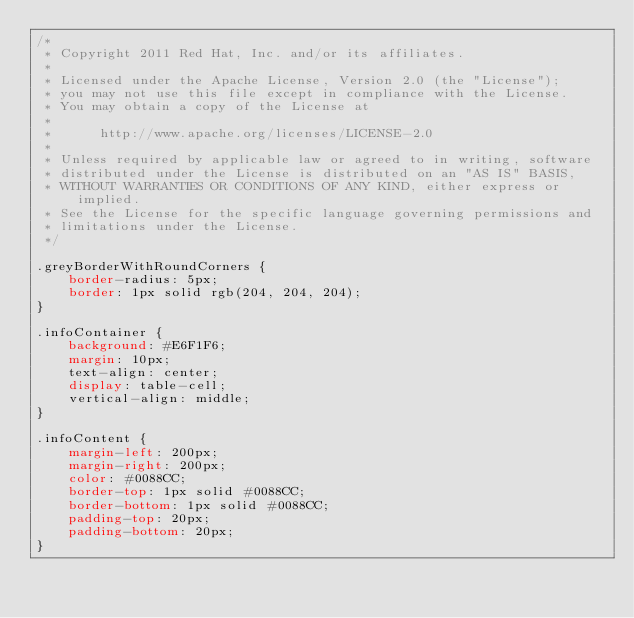Convert code to text. <code><loc_0><loc_0><loc_500><loc_500><_CSS_>/*
 * Copyright 2011 Red Hat, Inc. and/or its affiliates.
 *
 * Licensed under the Apache License, Version 2.0 (the "License");
 * you may not use this file except in compliance with the License.
 * You may obtain a copy of the License at
 *
 *      http://www.apache.org/licenses/LICENSE-2.0
 *
 * Unless required by applicable law or agreed to in writing, software
 * distributed under the License is distributed on an "AS IS" BASIS,
 * WITHOUT WARRANTIES OR CONDITIONS OF ANY KIND, either express or implied.
 * See the License for the specific language governing permissions and
 * limitations under the License.
 */

.greyBorderWithRoundCorners {
    border-radius: 5px;
    border: 1px solid rgb(204, 204, 204);
}

.infoContainer {
    background: #E6F1F6;
    margin: 10px;
    text-align: center;
    display: table-cell;
    vertical-align: middle;
}

.infoContent {
    margin-left: 200px;
    margin-right: 200px;
    color: #0088CC;
    border-top: 1px solid #0088CC;
    border-bottom: 1px solid #0088CC;
    padding-top: 20px;
    padding-bottom: 20px;
}
</code> 